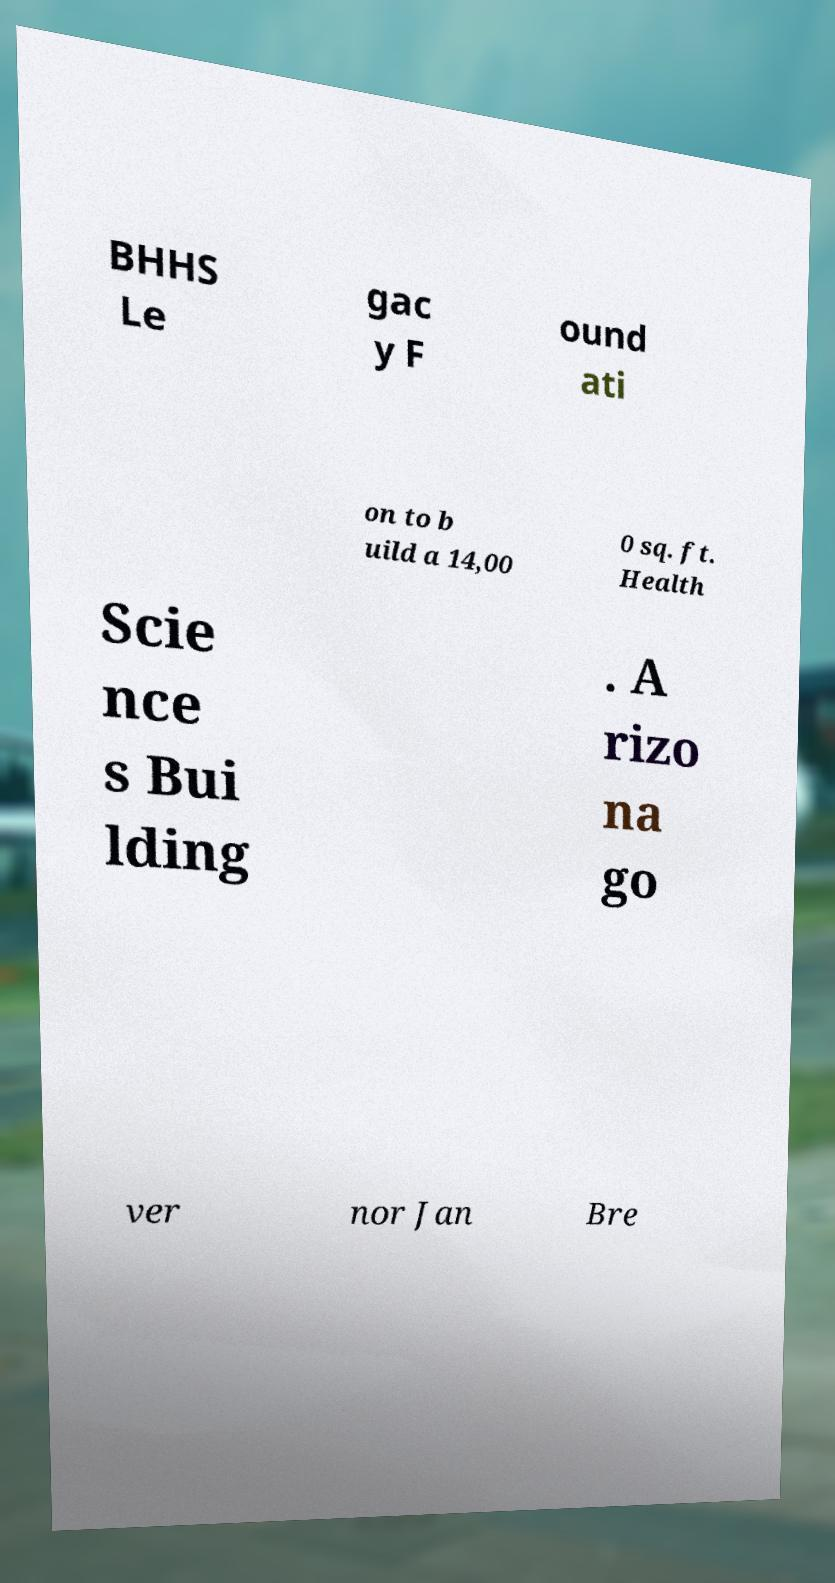What messages or text are displayed in this image? I need them in a readable, typed format. BHHS Le gac y F ound ati on to b uild a 14,00 0 sq. ft. Health Scie nce s Bui lding . A rizo na go ver nor Jan Bre 